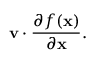<formula> <loc_0><loc_0><loc_500><loc_500>v \cdot { \frac { \partial f ( x ) } { \partial x } } .</formula> 